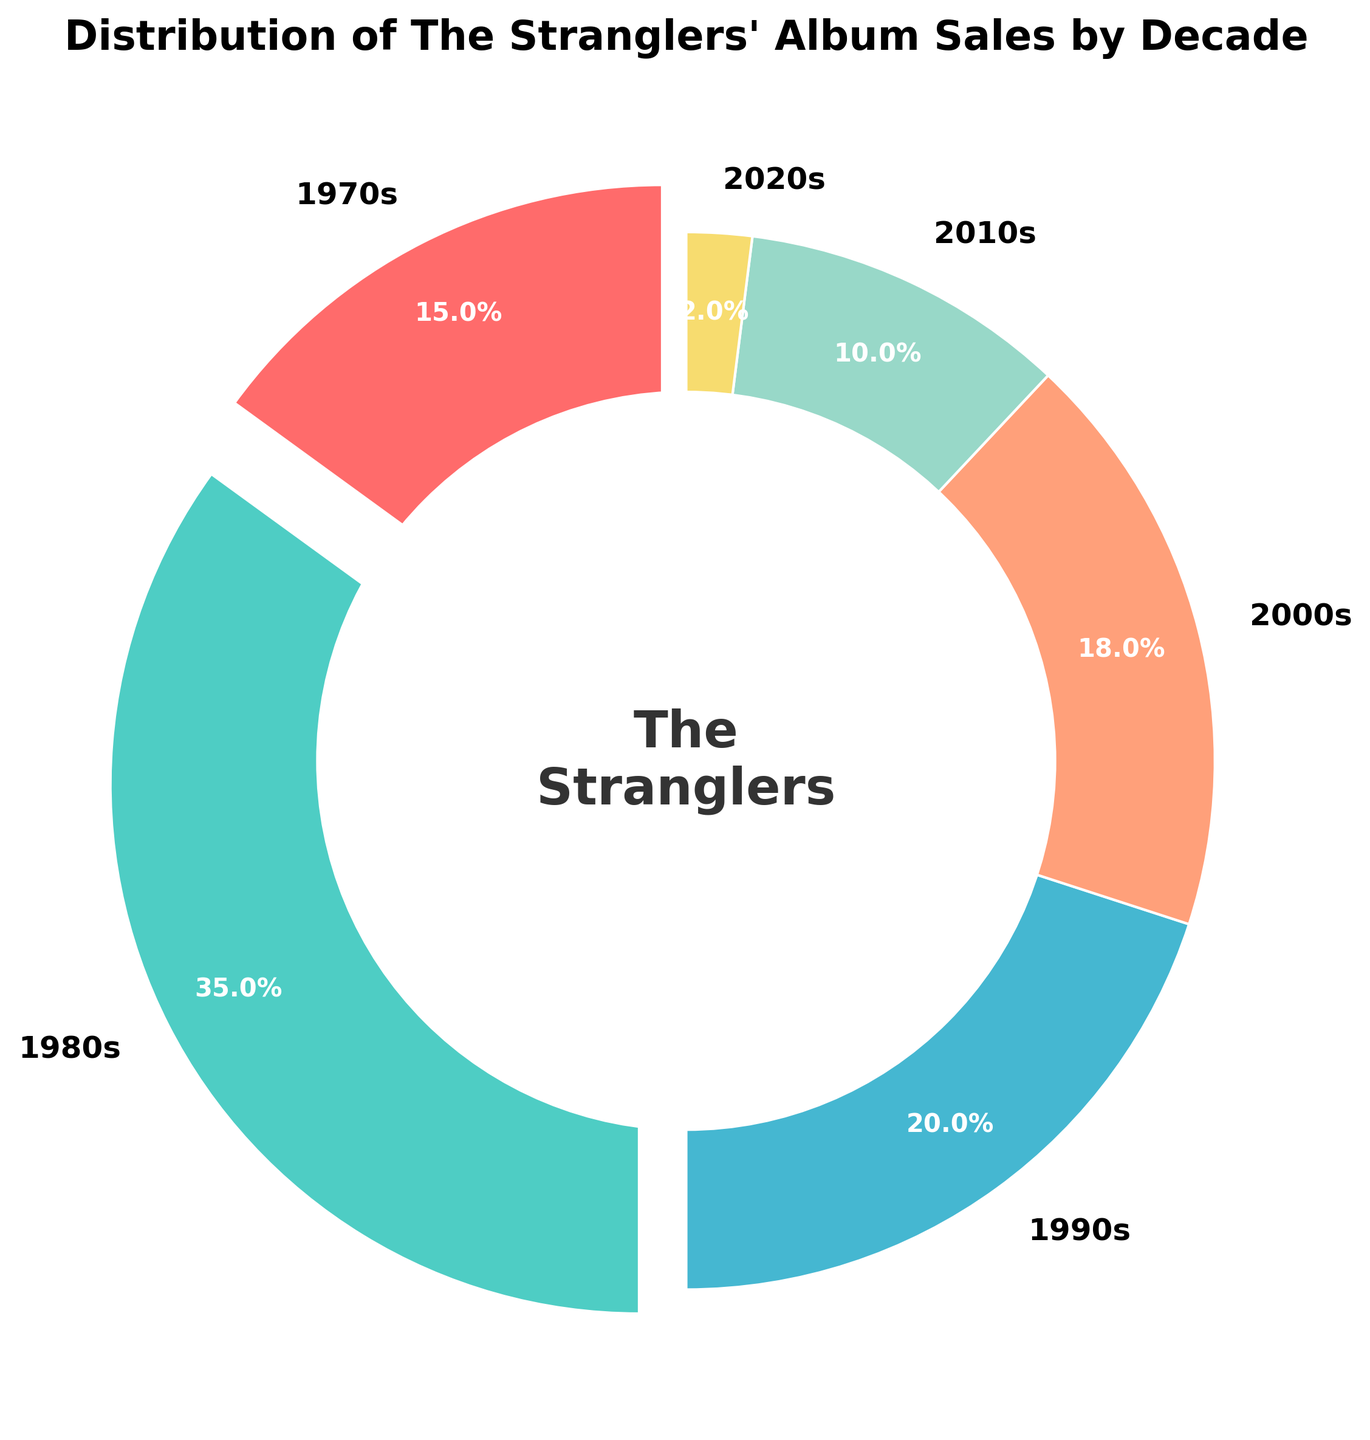What's the decade with the highest album sales percentage for The Stranglers? The figure shows that the 1980s segment occupies the largest part of the pie chart. In terms of numerical percentage, it also lists 35%, which is higher than any other decade.
Answer: 1980s Between the 1990s and the 2000s, which decade had a higher percentage of album sales? Comparing the pie segments for the 1990s and the 2000s, the 1990s have 20% while the 2000s have 18%. Therefore, the 1990s have a higher percentage.
Answer: 1990s What is the combined percentage of album sales for the 2010s and 2020s? The figure shows the percentages for the 2010s and 2020s as 10% and 2% respectively. Adding these together, we get 10% + 2% = 12%.
Answer: 12% Which decade has the smallest segment, and what color is it? The smallest segment in the pie chart is for the 2020s, given at 2%. The color of this segment is yellow.
Answer: 2020s, yellow How much larger is the album sales percentage in the 1980s compared to the 2000s? The pie chart shows percentages for the 1980s at 35% and the 2000s at 18%. To find the difference, subtract 18 from 35: 35% - 18% = 17%.
Answer: 17% What do the colors red and green represent in the pie chart? The red segment represents the 1970s, and the green segment represents the 1980s.
Answer: 1970s and 1980s What's the average album sales percentage from the 1970s, 1990s, and 2000s? Sum the percentages for these decades: 15% (1970s) + 20% (1990s) + 18% (2000s) = 53%. Divide this by 3 to find the average: 53% / 3 ≈ 17.67%.
Answer: ≈17.67% Which two decades have segments that are equally exploded out from the center, and what are their percentages? Observing the pie chart, the 1970s and 1980s segments are both exploded out equally. The 1970s represent 15%, and the 1980s represent 35%.
Answer: 1970s: 15%, 1980s: 35% What percentage of total album sales do the decades before the 1990s account for? Summing the percentages for the 1970s (15%) and the 1980s (35%), we get 15% + 35% = 50%.
Answer: 50% What is the sum of the album sales percentages for the 2010s and all subsequent decades? The figure shows percentages for the 2010s (10%) and 2020s (2%). Adding these together, we get 10% + 2% = 12%.
Answer: 12% 